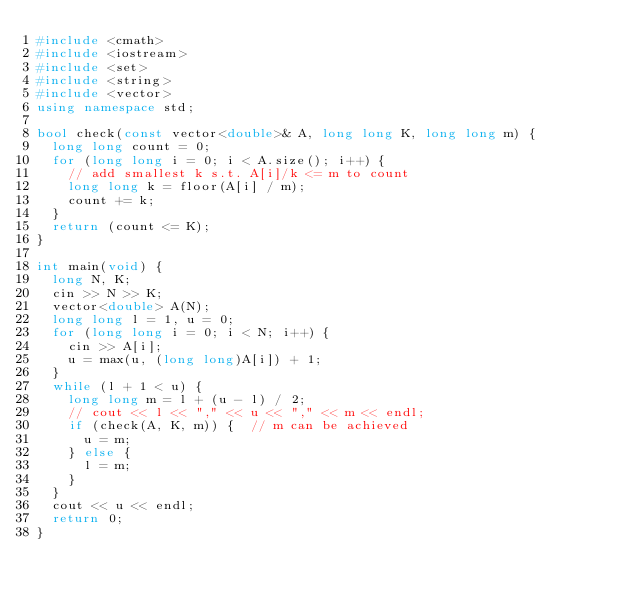Convert code to text. <code><loc_0><loc_0><loc_500><loc_500><_C++_>#include <cmath>
#include <iostream>
#include <set>
#include <string>
#include <vector>
using namespace std;

bool check(const vector<double>& A, long long K, long long m) {
  long long count = 0;
  for (long long i = 0; i < A.size(); i++) {
    // add smallest k s.t. A[i]/k <= m to count
    long long k = floor(A[i] / m);
    count += k;
  }
  return (count <= K);
}

int main(void) {
  long N, K;
  cin >> N >> K;
  vector<double> A(N);
  long long l = 1, u = 0;
  for (long long i = 0; i < N; i++) {
    cin >> A[i];
    u = max(u, (long long)A[i]) + 1;
  }
  while (l + 1 < u) {
    long long m = l + (u - l) / 2;
    // cout << l << "," << u << "," << m << endl;
    if (check(A, K, m)) {  // m can be achieved
      u = m;
    } else {
      l = m;
    }
  }
  cout << u << endl;
  return 0;
}</code> 